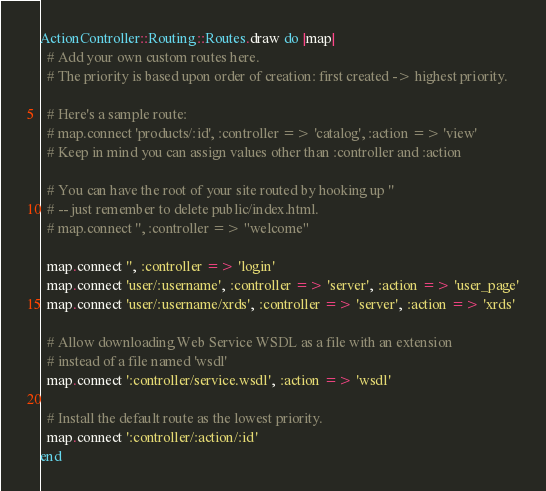Convert code to text. <code><loc_0><loc_0><loc_500><loc_500><_Ruby_>ActionController::Routing::Routes.draw do |map|
  # Add your own custom routes here.
  # The priority is based upon order of creation: first created -> highest priority.
  
  # Here's a sample route:
  # map.connect 'products/:id', :controller => 'catalog', :action => 'view'
  # Keep in mind you can assign values other than :controller and :action

  # You can have the root of your site routed by hooking up '' 
  # -- just remember to delete public/index.html.
  # map.connect '', :controller => "welcome"

  map.connect '', :controller => 'login'
  map.connect 'user/:username', :controller => 'server', :action => 'user_page'
  map.connect 'user/:username/xrds', :controller => 'server', :action => 'xrds'

  # Allow downloading Web Service WSDL as a file with an extension
  # instead of a file named 'wsdl'
  map.connect ':controller/service.wsdl', :action => 'wsdl'

  # Install the default route as the lowest priority.
  map.connect ':controller/:action/:id'
end
</code> 